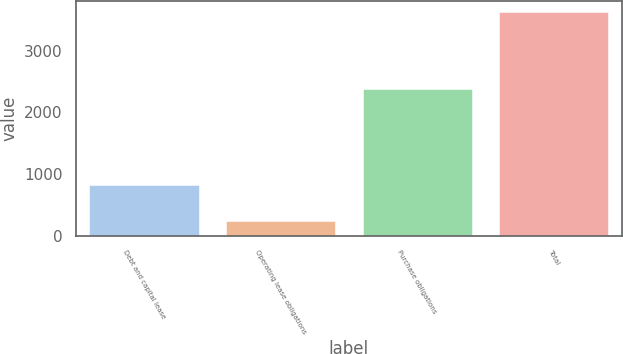<chart> <loc_0><loc_0><loc_500><loc_500><bar_chart><fcel>Debt and capital lease<fcel>Operating lease obligations<fcel>Purchase obligations<fcel>Total<nl><fcel>811<fcel>236<fcel>2375<fcel>3620<nl></chart> 